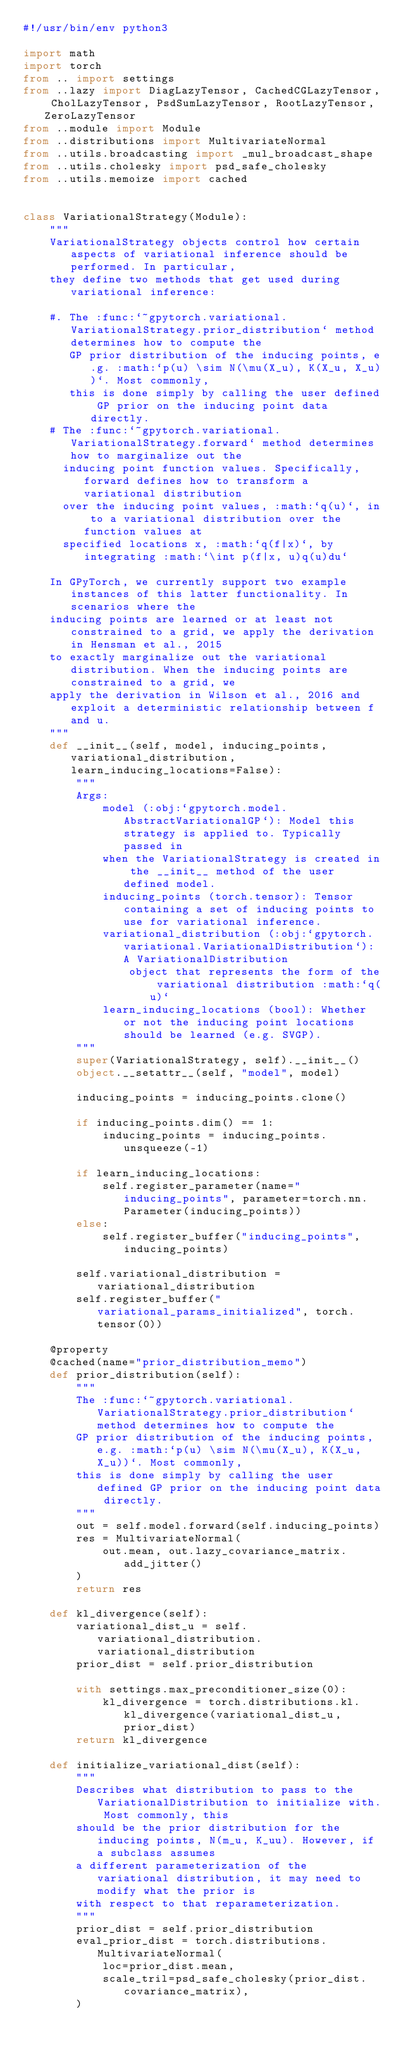Convert code to text. <code><loc_0><loc_0><loc_500><loc_500><_Python_>#!/usr/bin/env python3

import math
import torch
from .. import settings
from ..lazy import DiagLazyTensor, CachedCGLazyTensor, CholLazyTensor, PsdSumLazyTensor, RootLazyTensor, ZeroLazyTensor
from ..module import Module
from ..distributions import MultivariateNormal
from ..utils.broadcasting import _mul_broadcast_shape
from ..utils.cholesky import psd_safe_cholesky
from ..utils.memoize import cached


class VariationalStrategy(Module):
    """
    VariationalStrategy objects control how certain aspects of variational inference should be performed. In particular,
    they define two methods that get used during variational inference:

    #. The :func:`~gpytorch.variational.VariationalStrategy.prior_distribution` method determines how to compute the
       GP prior distribution of the inducing points, e.g. :math:`p(u) \sim N(\mu(X_u), K(X_u, X_u))`. Most commonly,
       this is done simply by calling the user defined GP prior on the inducing point data directly.
    # The :func:`~gpytorch.variational.VariationalStrategy.forward` method determines how to marginalize out the
      inducing point function values. Specifically, forward defines how to transform a variational distribution
      over the inducing point values, :math:`q(u)`, in to a variational distribution over the function values at
      specified locations x, :math:`q(f|x)`, by integrating :math:`\int p(f|x, u)q(u)du`

    In GPyTorch, we currently support two example instances of this latter functionality. In scenarios where the
    inducing points are learned or at least not constrained to a grid, we apply the derivation in Hensman et al., 2015
    to exactly marginalize out the variational distribution. When the inducing points are constrained to a grid, we
    apply the derivation in Wilson et al., 2016 and exploit a deterministic relationship between f and u.
    """
    def __init__(self, model, inducing_points, variational_distribution, learn_inducing_locations=False):
        """
        Args:
            model (:obj:`gpytorch.model.AbstractVariationalGP`): Model this strategy is applied to. Typically passed in
            when the VariationalStrategy is created in the __init__ method of the user defined model.
            inducing_points (torch.tensor): Tensor containing a set of inducing points to use for variational inference.
            variational_distribution (:obj:`gpytorch.variational.VariationalDistribution`): A VariationalDistribution
                object that represents the form of the variational distribution :math:`q(u)`
            learn_inducing_locations (bool): Whether or not the inducing point locations should be learned (e.g. SVGP).
        """
        super(VariationalStrategy, self).__init__()
        object.__setattr__(self, "model", model)

        inducing_points = inducing_points.clone()

        if inducing_points.dim() == 1:
            inducing_points = inducing_points.unsqueeze(-1)

        if learn_inducing_locations:
            self.register_parameter(name="inducing_points", parameter=torch.nn.Parameter(inducing_points))
        else:
            self.register_buffer("inducing_points", inducing_points)

        self.variational_distribution = variational_distribution
        self.register_buffer("variational_params_initialized", torch.tensor(0))

    @property
    @cached(name="prior_distribution_memo")
    def prior_distribution(self):
        """
        The :func:`~gpytorch.variational.VariationalStrategy.prior_distribution` method determines how to compute the
        GP prior distribution of the inducing points, e.g. :math:`p(u) \sim N(\mu(X_u), K(X_u, X_u))`. Most commonly,
        this is done simply by calling the user defined GP prior on the inducing point data directly.
        """
        out = self.model.forward(self.inducing_points)
        res = MultivariateNormal(
            out.mean, out.lazy_covariance_matrix.add_jitter()
        )
        return res

    def kl_divergence(self):
        variational_dist_u = self.variational_distribution.variational_distribution
        prior_dist = self.prior_distribution

        with settings.max_preconditioner_size(0):
            kl_divergence = torch.distributions.kl.kl_divergence(variational_dist_u, prior_dist)
        return kl_divergence

    def initialize_variational_dist(self):
        """
        Describes what distribution to pass to the VariationalDistribution to initialize with. Most commonly, this
        should be the prior distribution for the inducing points, N(m_u, K_uu). However, if a subclass assumes
        a different parameterization of the variational distribution, it may need to modify what the prior is
        with respect to that reparameterization.
        """
        prior_dist = self.prior_distribution
        eval_prior_dist = torch.distributions.MultivariateNormal(
            loc=prior_dist.mean,
            scale_tril=psd_safe_cholesky(prior_dist.covariance_matrix),
        )</code> 